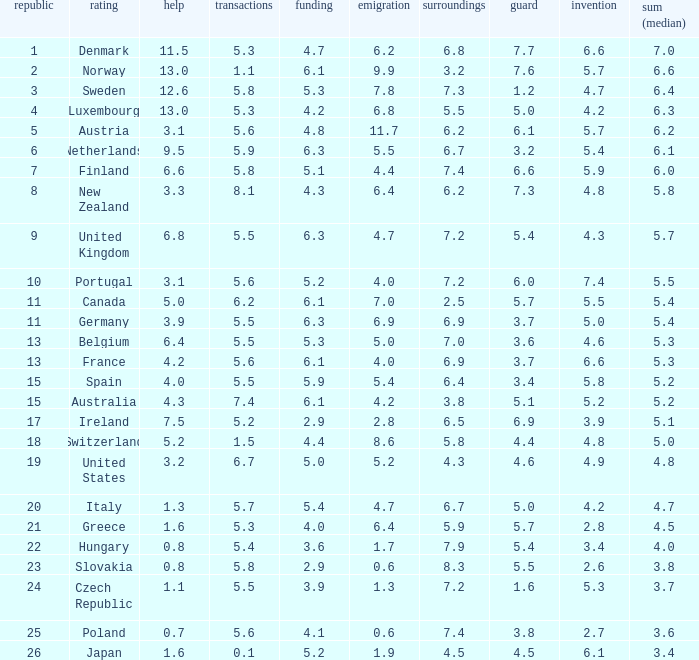How many times is denmark ranked in technology? 1.0. 